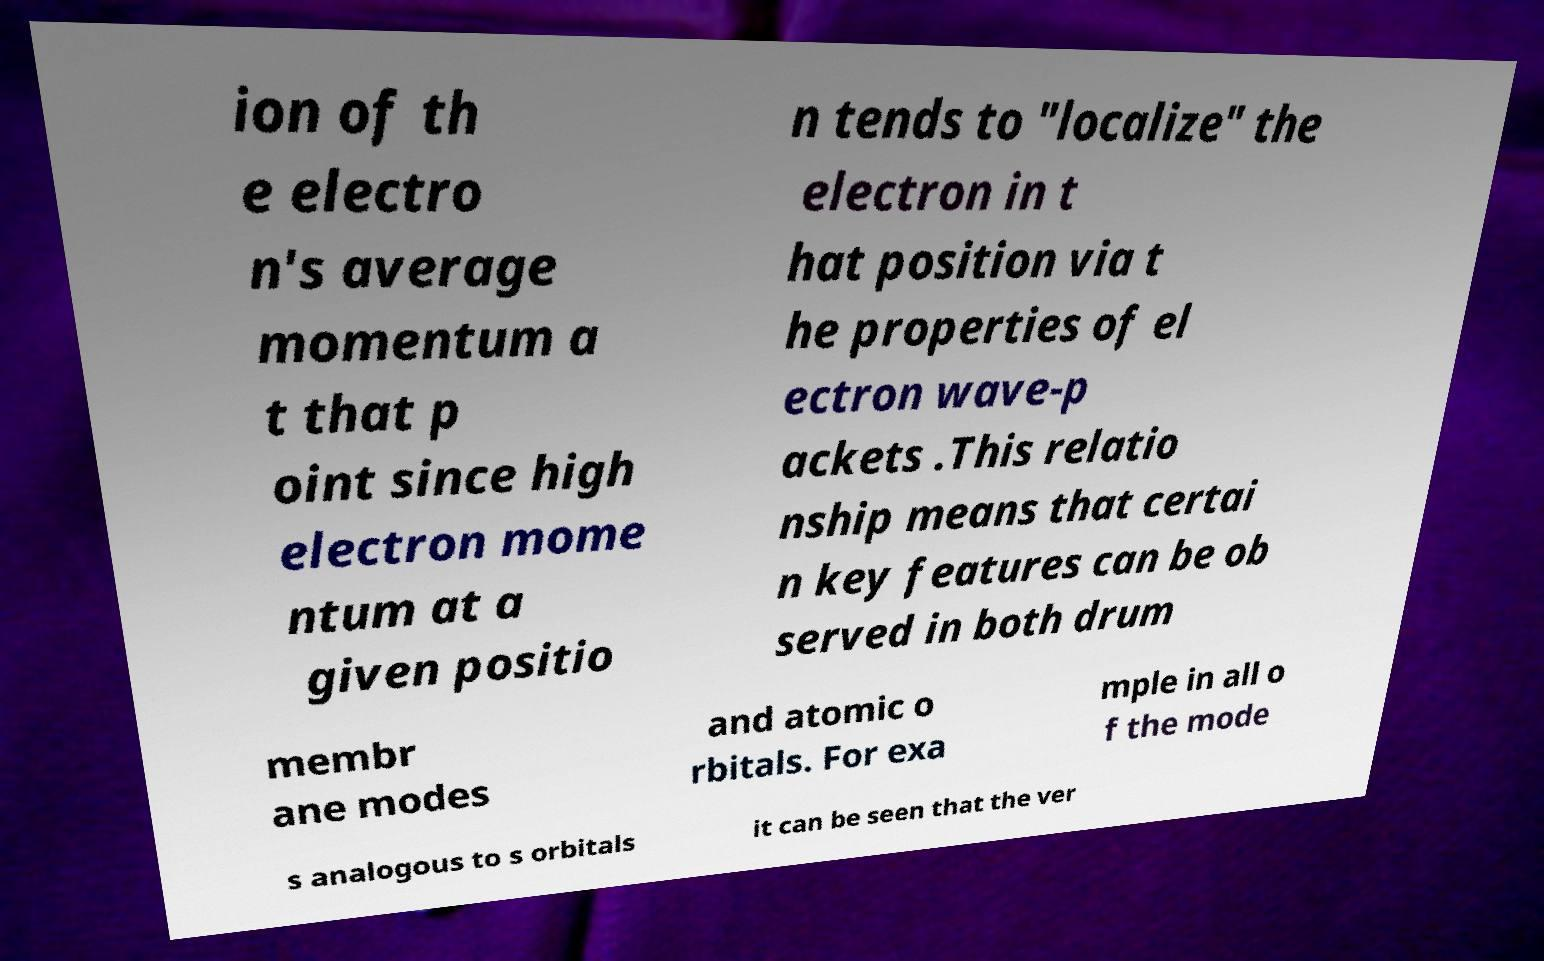For documentation purposes, I need the text within this image transcribed. Could you provide that? ion of th e electro n's average momentum a t that p oint since high electron mome ntum at a given positio n tends to "localize" the electron in t hat position via t he properties of el ectron wave-p ackets .This relatio nship means that certai n key features can be ob served in both drum membr ane modes and atomic o rbitals. For exa mple in all o f the mode s analogous to s orbitals it can be seen that the ver 